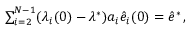Convert formula to latex. <formula><loc_0><loc_0><loc_500><loc_500>\begin{array} { r } { \sum _ { i = 2 } ^ { N - 1 } ( \lambda _ { i } ( 0 ) - \lambda ^ { * } ) a _ { i } \hat { e } _ { i } ( 0 ) = \hat { e } ^ { * } \, , } \end{array}</formula> 